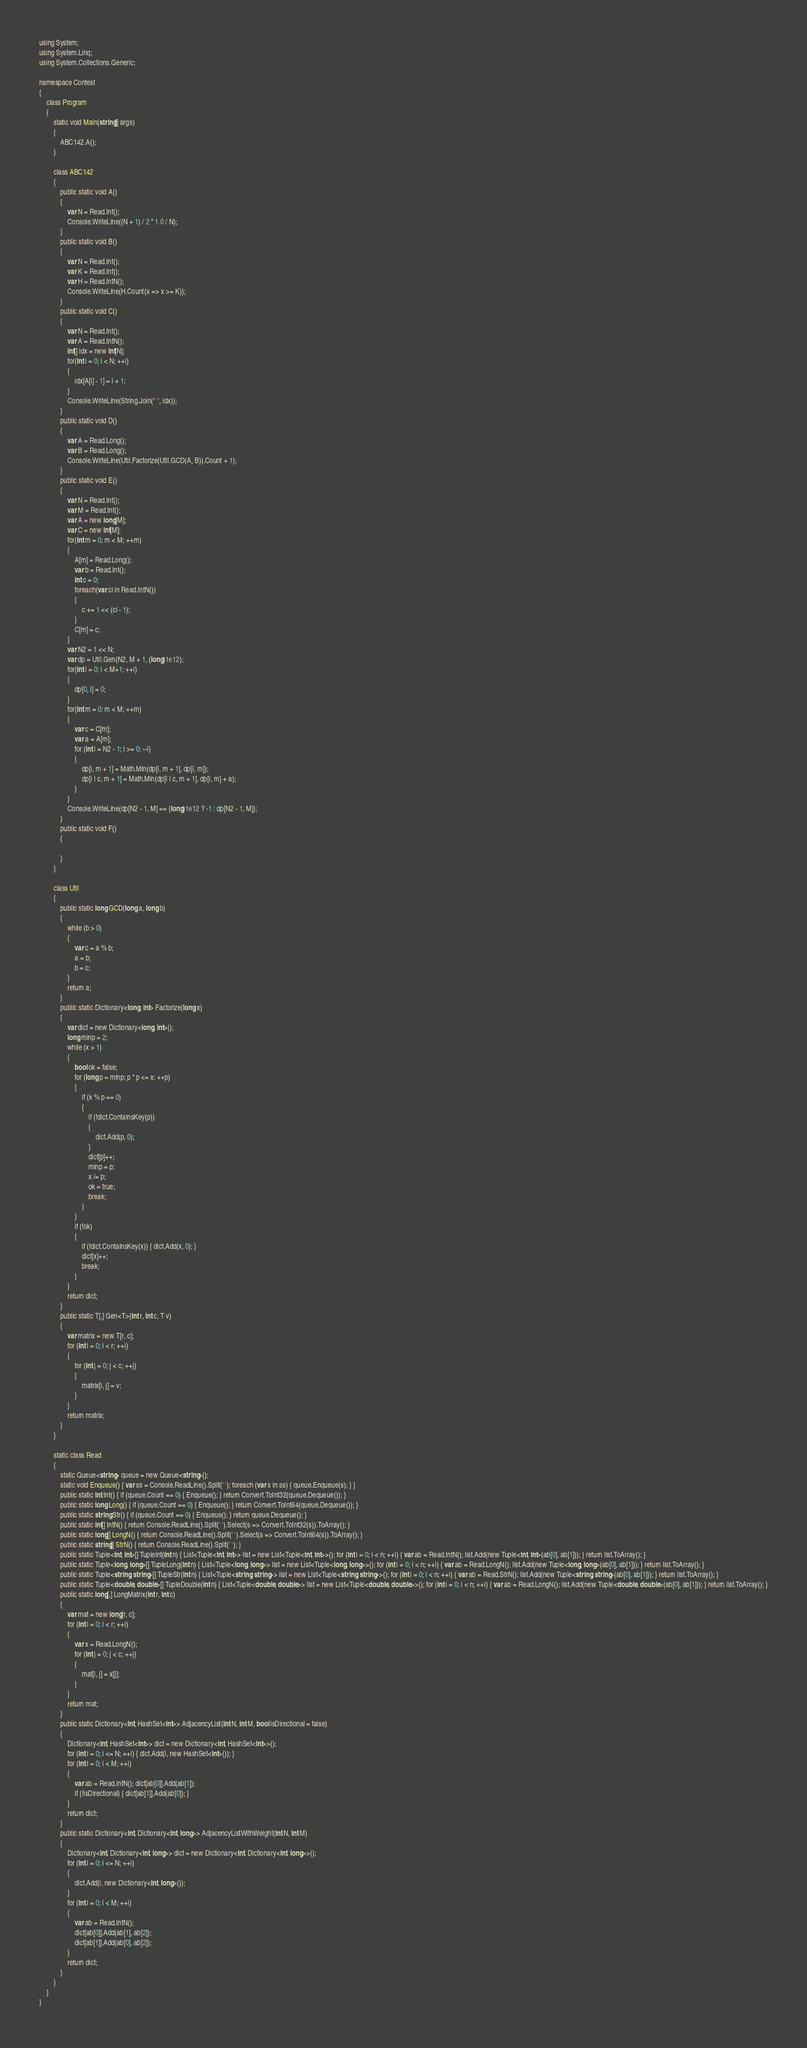<code> <loc_0><loc_0><loc_500><loc_500><_C#_>using System;
using System.Linq;
using System.Collections.Generic;

namespace Contest
{
    class Program
    {
        static void Main(string[] args)
        {
            ABC142.A();
        }

        class ABC142
        {
            public static void A()
            {
                var N = Read.Int();
                Console.WriteLine((N + 1) / 2 * 1.0 / N);
            }
            public static void B()
            {
                var N = Read.Int();
                var K = Read.Int();
                var H = Read.IntN();
                Console.WriteLine(H.Count(x => x >= K));
            }
            public static void C()
            {
                var N = Read.Int();
                var A = Read.IntN();
                int[] idx = new int[N];
                for(int i = 0; i < N; ++i)
                {
                    idx[A[i] - 1] = i + 1;
                }
                Console.WriteLine(String.Join(" ", idx));
            }
            public static void D()
            {
                var A = Read.Long();
                var B = Read.Long();
                Console.WriteLine(Util.Factorize(Util.GCD(A, B)).Count + 1);
            }
            public static void E()
            {
                var N = Read.Int();
                var M = Read.Int();
                var A = new long[M];
                var C = new int[M];
                for(int m = 0; m < M; ++m)
                {
                    A[m] = Read.Long();
                    var b = Read.Int();
                    int c = 0;
                    foreach(var ci in Read.IntN())
                    {
                        c += 1 << (ci - 1);
                    }
                    C[m] = c;
                }
                var N2 = 1 << N;
                var dp = Util.Gen(N2, M + 1, (long)1e12);
                for(int i = 0; i < M+1; ++i)
                {
                    dp[0, i] = 0;
                }
                for(int m = 0; m < M; ++m)
                {
                    var c = C[m];
                    var a = A[m];
                    for (int i = N2 - 1; i >= 0; --i)
                    {
                        dp[i, m + 1] = Math.Min(dp[i, m + 1], dp[i, m]);
                        dp[i | c, m + 1] = Math.Min(dp[i | c, m + 1], dp[i, m] + a);
                    }
                }
                Console.WriteLine(dp[N2 - 1, M] == (long)1e12 ? -1 : dp[N2 - 1, M]);
            }
            public static void F()
            {

            }
        }

        class Util
        {
            public static long GCD(long a, long b)
            {
                while (b > 0)
                {
                    var c = a % b;
                    a = b;
                    b = c;
                }
                return a;
            }
            public static Dictionary<long, int> Factorize(long x)
            {
                var dict = new Dictionary<long, int>();
                long minp = 2;
                while (x > 1)
                {
                    bool ok = false;
                    for (long p = minp; p * p <= x; ++p)
                    {
                        if (x % p == 0)
                        {
                            if (!dict.ContainsKey(p))
                            {
                                dict.Add(p, 0);
                            }
                            dict[p]++;
                            minp = p;
                            x /= p;
                            ok = true;
                            break;
                        }
                    }
                    if (!ok)
                    {
                        if (!dict.ContainsKey(x)) { dict.Add(x, 0); }
                        dict[x]++;
                        break;
                    }
                }
                return dict;
            }
            public static T[,] Gen<T>(int r, int c, T v)
            {
                var matrix = new T[r, c];
                for (int i = 0; i < r; ++i)
                {
                    for (int j = 0; j < c; ++j)
                    {
                        matrix[i, j] = v;
                    }
                }
                return matrix;
            }
        }

        static class Read
        {
            static Queue<string> queue = new Queue<string>();
            static void Enqueue() { var ss = Console.ReadLine().Split(' '); foreach (var s in ss) { queue.Enqueue(s); } }
            public static int Int() { if (queue.Count == 0) { Enqueue(); } return Convert.ToInt32(queue.Dequeue()); }
            public static long Long() { if (queue.Count == 0) { Enqueue(); } return Convert.ToInt64(queue.Dequeue()); }
            public static string Str() { if (queue.Count == 0) { Enqueue(); } return queue.Dequeue(); }
            public static int[] IntN() { return Console.ReadLine().Split(' ').Select(s => Convert.ToInt32(s)).ToArray(); }
            public static long[] LongN() { return Console.ReadLine().Split(' ').Select(s => Convert.ToInt64(s)).ToArray(); }
            public static string[] StrN() { return Console.ReadLine().Split(' '); }
            public static Tuple<int, int>[] TupleInt(int n) { List<Tuple<int, int>> list = new List<Tuple<int, int>>(); for (int i = 0; i < n; ++i) { var ab = Read.IntN(); list.Add(new Tuple<int, int>(ab[0], ab[1])); } return list.ToArray(); }
            public static Tuple<long, long>[] TupleLong(int n) { List<Tuple<long, long>> list = new List<Tuple<long, long>>(); for (int i = 0; i < n; ++i) { var ab = Read.LongN(); list.Add(new Tuple<long, long>(ab[0], ab[1])); } return list.ToArray(); }
            public static Tuple<string, string>[] TupleStr(int n) { List<Tuple<string, string>> list = new List<Tuple<string, string>>(); for (int i = 0; i < n; ++i) { var ab = Read.StrN(); list.Add(new Tuple<string, string>(ab[0], ab[1])); } return list.ToArray(); }
            public static Tuple<double, double>[] TupleDouble(int n) { List<Tuple<double, double>> list = new List<Tuple<double, double>>(); for (int i = 0; i < n; ++i) { var ab = Read.LongN(); list.Add(new Tuple<double, double>(ab[0], ab[1])); } return list.ToArray(); }
            public static long[,] LongMatrix(int r, int c)
            {
                var mat = new long[r, c];
                for (int i = 0; i < r; ++i)
                {
                    var x = Read.LongN();
                    for (int j = 0; j < c; ++j)
                    {
                        mat[i, j] = x[j];
                    }
                }
                return mat;
            }
            public static Dictionary<int, HashSet<int>> AdjacencyList(int N, int M, bool isDirectional = false)
            {
                Dictionary<int, HashSet<int>> dict = new Dictionary<int, HashSet<int>>();
                for (int i = 0; i <= N; ++i) { dict.Add(i, new HashSet<int>()); }
                for (int i = 0; i < M; ++i)
                {
                    var ab = Read.IntN(); dict[ab[0]].Add(ab[1]);
                    if (!isDirectional) { dict[ab[1]].Add(ab[0]); }
                }
                return dict;
            }
            public static Dictionary<int, Dictionary<int, long>> AdjacencyListWithWeight(int N, int M)
            {
                Dictionary<int, Dictionary<int, long>> dict = new Dictionary<int, Dictionary<int, long>>();
                for (int i = 0; i <= N; ++i)
                {
                    dict.Add(i, new Dictionary<int, long>());
                }
                for (int i = 0; i < M; ++i)
                {
                    var ab = Read.IntN();
                    dict[ab[0]].Add(ab[1], ab[2]);
                    dict[ab[1]].Add(ab[0], ab[2]);
                }
                return dict;
            }
        }
    }
}
</code> 